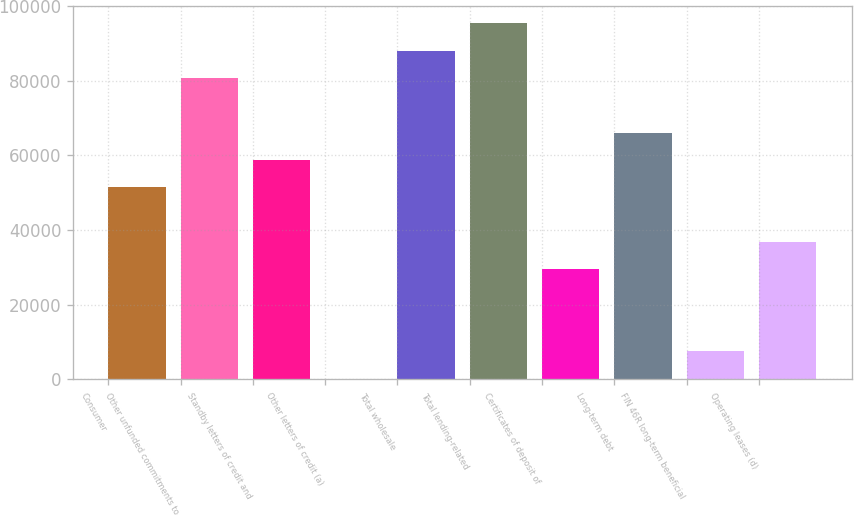Convert chart to OTSL. <chart><loc_0><loc_0><loc_500><loc_500><bar_chart><fcel>Consumer<fcel>Other unfunded commitments to<fcel>Standby letters of credit and<fcel>Other letters of credit (a)<fcel>Total wholesale<fcel>Total lending-related<fcel>Certificates of deposit of<fcel>Long-term debt<fcel>FIN 46R long-term beneficial<fcel>Operating leases (d)<nl><fcel>51411.1<fcel>80680.3<fcel>58728.4<fcel>190<fcel>87997.6<fcel>95314.9<fcel>29459.2<fcel>66045.7<fcel>7507.3<fcel>36776.5<nl></chart> 